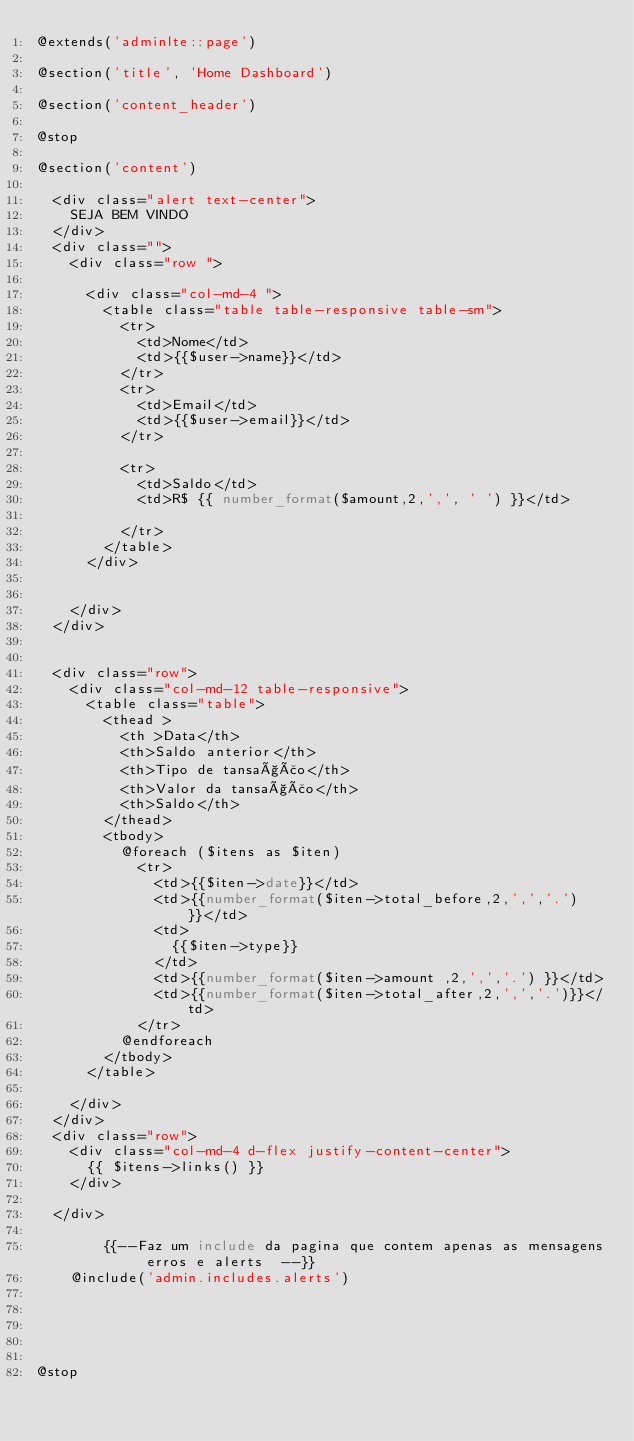<code> <loc_0><loc_0><loc_500><loc_500><_PHP_>@extends('adminlte::page')

@section('title', 'Home Dashboard')

@section('content_header')

@stop

@section('content')

  <div class="alert text-center">
    SEJA BEM VINDO
  </div>
  <div class="">
    <div class="row ">

      <div class="col-md-4 ">
        <table class="table table-responsive table-sm">
          <tr>
            <td>Nome</td>
            <td>{{$user->name}}</td>
          </tr>
          <tr>
            <td>Email</td>
            <td>{{$user->email}}</td>
          </tr>

          <tr>
            <td>Saldo</td>
            <td>R$ {{ number_format($amount,2,',', ' ') }}</td>

          </tr>
        </table>
      </div>


    </div>
  </div>


  <div class="row">
    <div class="col-md-12 table-responsive">
      <table class="table">
        <thead >
          <th >Data</th>
          <th>Saldo anterior</th>
          <th>Tipo de tansação</th>
          <th>Valor da tansação</th>
          <th>Saldo</th>
        </thead>
        <tbody>
          @foreach ($itens as $iten)
            <tr>
              <td>{{$iten->date}}</td>
              <td>{{number_format($iten->total_before,2,',','.')}}</td>
              <td>
                {{$iten->type}}
              </td>
              <td>{{number_format($iten->amount ,2,',','.') }}</td>
              <td>{{number_format($iten->total_after,2,',','.')}}</td>
            </tr>
          @endforeach
        </tbody>
      </table>

    </div>
  </div>
  <div class="row">
    <div class="col-md-4 d-flex justify-content-center">
      {{ $itens->links() }}
    </div>

  </div>

        {{--Faz um include da pagina que contem apenas as mensagens erros e alerts  --}}
    @include('admin.includes.alerts')





@stop
</code> 